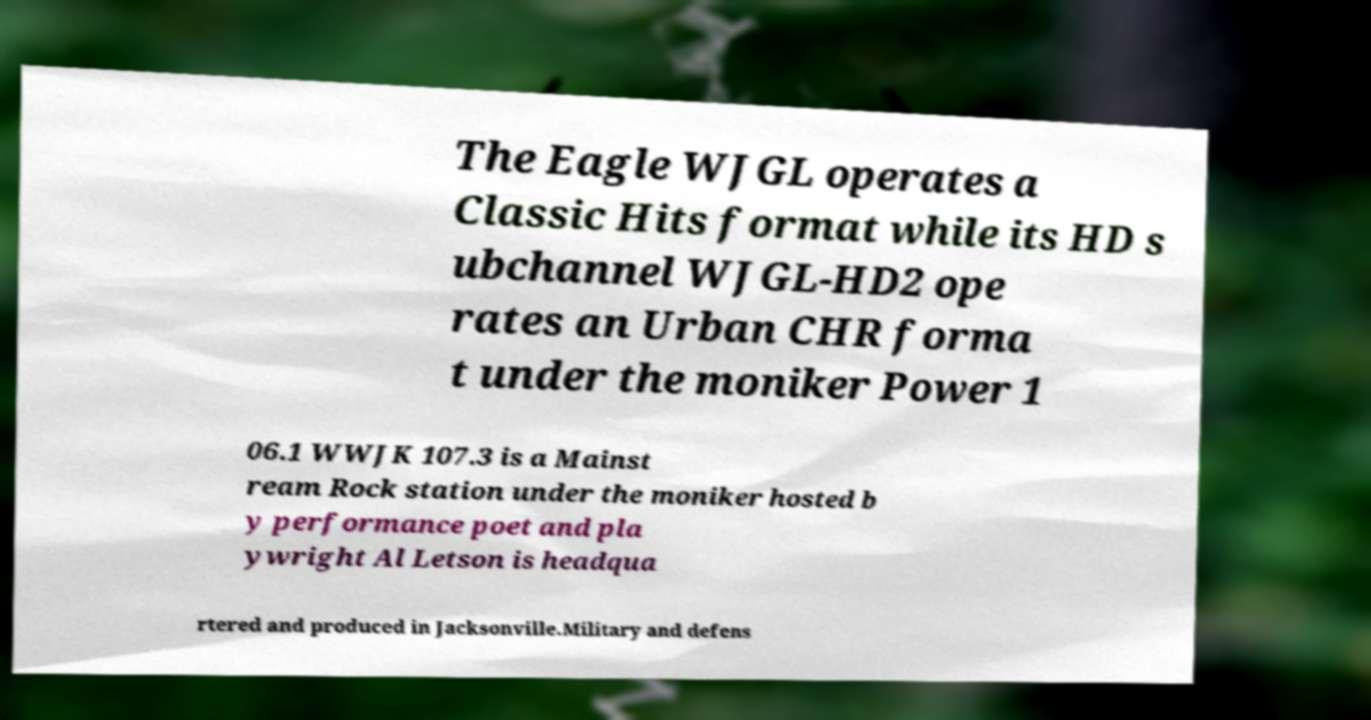Please identify and transcribe the text found in this image. The Eagle WJGL operates a Classic Hits format while its HD s ubchannel WJGL-HD2 ope rates an Urban CHR forma t under the moniker Power 1 06.1 WWJK 107.3 is a Mainst ream Rock station under the moniker hosted b y performance poet and pla ywright Al Letson is headqua rtered and produced in Jacksonville.Military and defens 